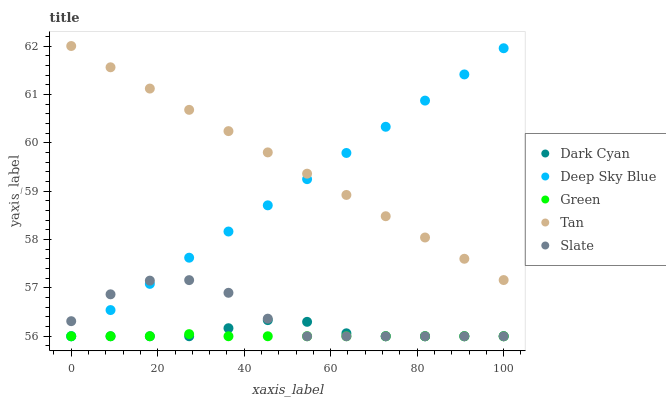Does Green have the minimum area under the curve?
Answer yes or no. Yes. Does Tan have the maximum area under the curve?
Answer yes or no. Yes. Does Tan have the minimum area under the curve?
Answer yes or no. No. Does Green have the maximum area under the curve?
Answer yes or no. No. Is Deep Sky Blue the smoothest?
Answer yes or no. Yes. Is Slate the roughest?
Answer yes or no. Yes. Is Tan the smoothest?
Answer yes or no. No. Is Tan the roughest?
Answer yes or no. No. Does Dark Cyan have the lowest value?
Answer yes or no. Yes. Does Tan have the lowest value?
Answer yes or no. No. Does Tan have the highest value?
Answer yes or no. Yes. Does Green have the highest value?
Answer yes or no. No. Is Dark Cyan less than Tan?
Answer yes or no. Yes. Is Tan greater than Dark Cyan?
Answer yes or no. Yes. Does Deep Sky Blue intersect Dark Cyan?
Answer yes or no. Yes. Is Deep Sky Blue less than Dark Cyan?
Answer yes or no. No. Is Deep Sky Blue greater than Dark Cyan?
Answer yes or no. No. Does Dark Cyan intersect Tan?
Answer yes or no. No. 